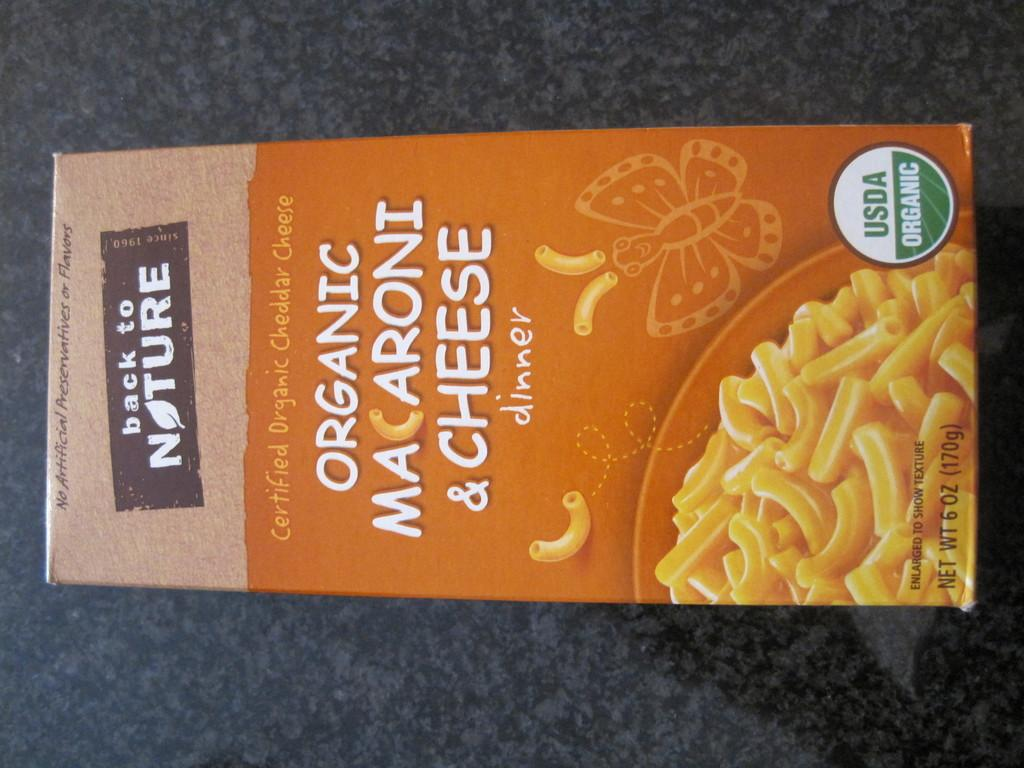Provide a one-sentence caption for the provided image. Back to nature mac n cheese organic box. 